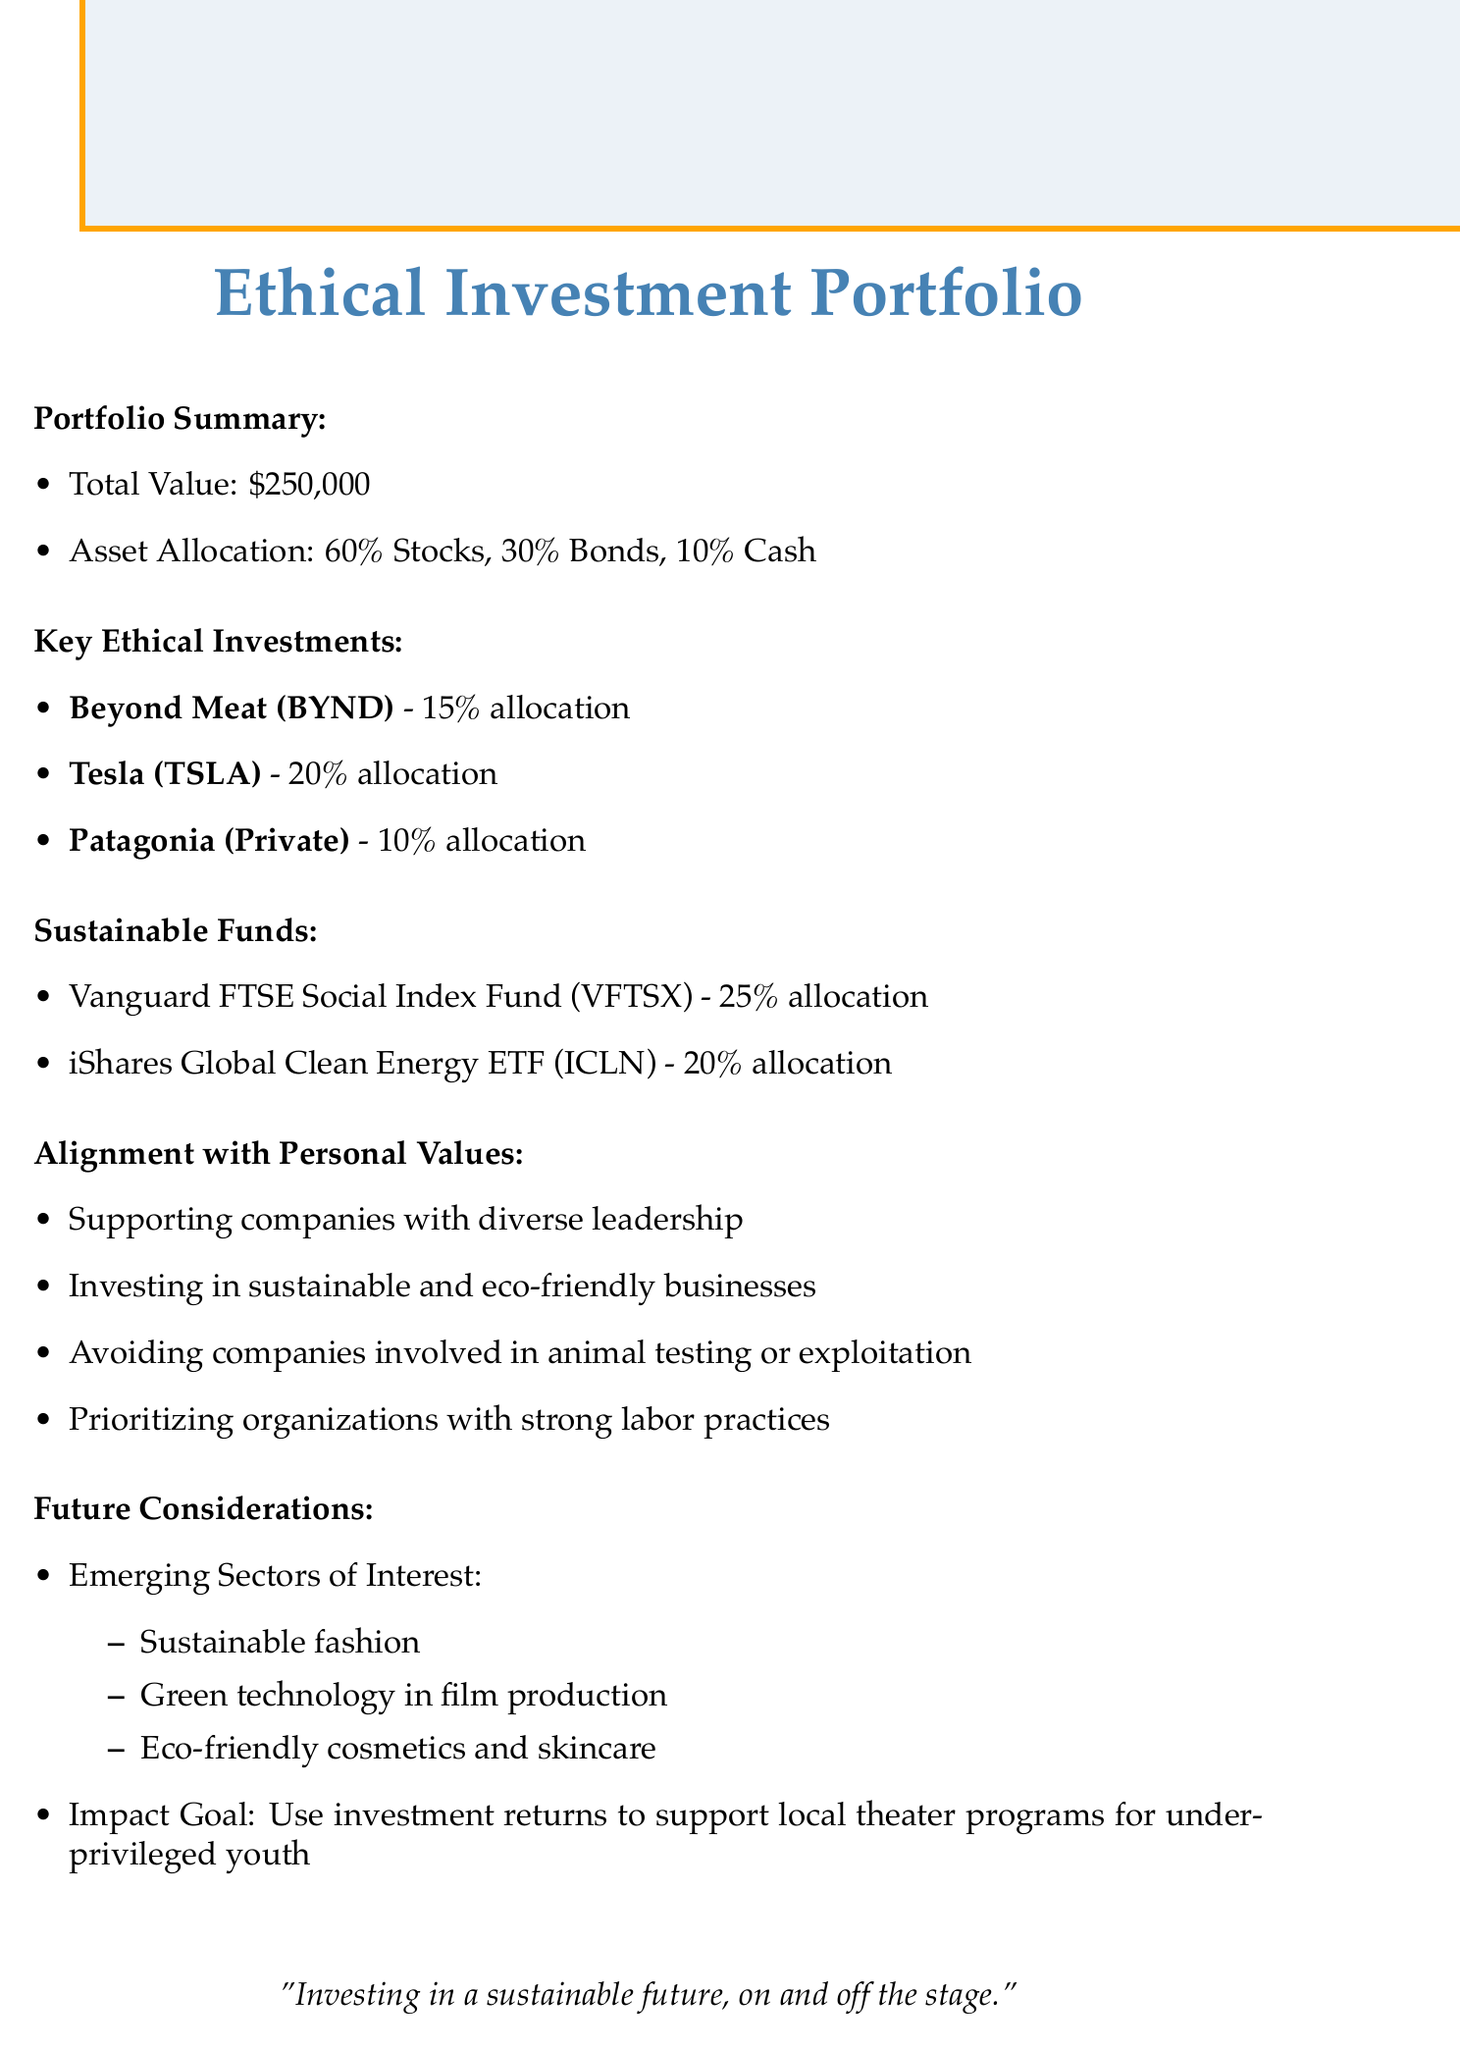What is the total value of the portfolio? The total value of the portfolio is given in the summary section of the document.
Answer: $250,000 What percentage of the portfolio is allocated to bonds? The portfolio summary provides the asset allocation in percentages for each asset type.
Answer: 30% Which company has a 20% allocation? This information can be found in the key ethical investments section, which lists the allocation percentages for each company.
Answer: Tesla What are the emerging sectors of interest? The future considerations section lists the emerging sectors that are of interest for future investments.
Answer: Sustainable fashion, Green technology in film production, Eco-friendly cosmetics and skincare What is the impact goal stated in the document? The future considerations section describes the intended impact goal of using investment returns.
Answer: Use investment returns to support local theater programs for underprivileged youth What is the allocation percentage for the Vanguard FTSE Social Index Fund? The sustainable funds section provides the allocation for each fund, including the Vanguard FTSE Social Index Fund.
Answer: 25% What company is involved in ethical manufacturing practices? The key ethical investments section includes companies with specific ethical considerations, including one focused on ethical manufacturing.
Answer: Patagonia What is one of the personal values aligned with the investments? The alignment with personal values section lists values that guide the investment choices.
Answer: Investing in sustainable and eco-friendly businesses 